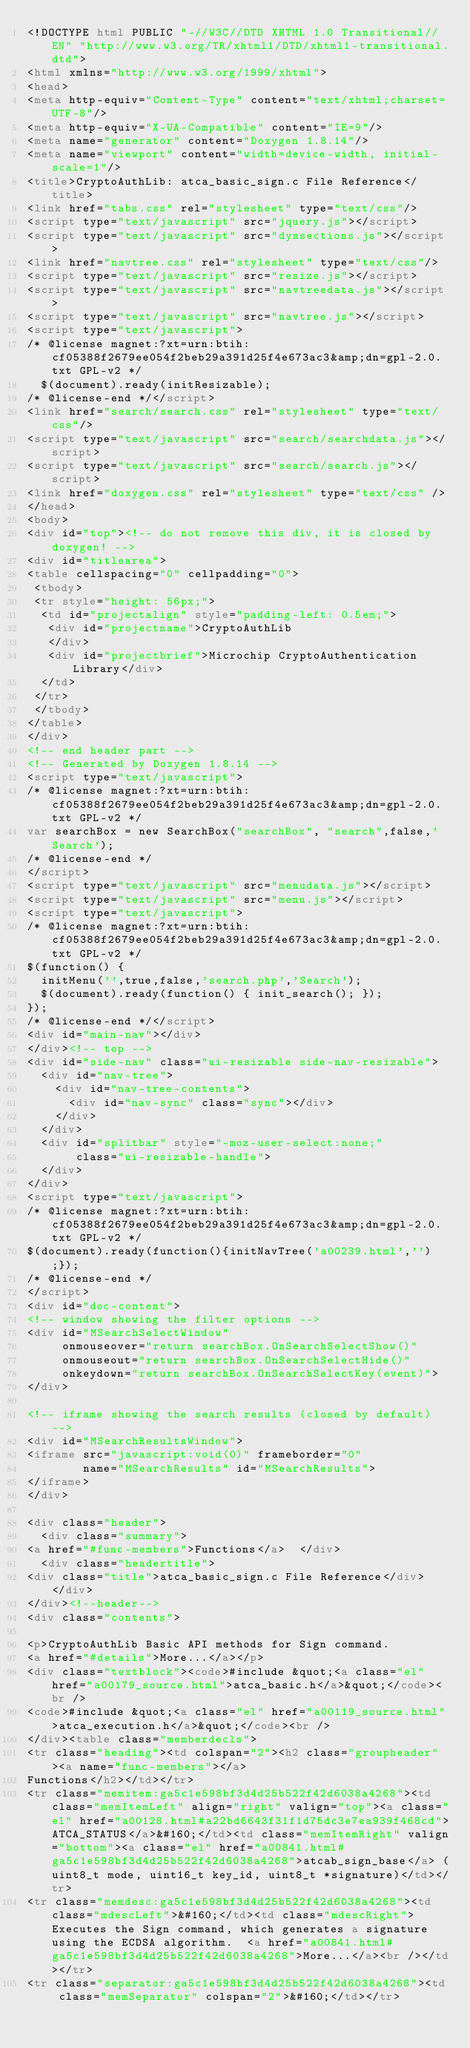<code> <loc_0><loc_0><loc_500><loc_500><_HTML_><!DOCTYPE html PUBLIC "-//W3C//DTD XHTML 1.0 Transitional//EN" "http://www.w3.org/TR/xhtml1/DTD/xhtml1-transitional.dtd">
<html xmlns="http://www.w3.org/1999/xhtml">
<head>
<meta http-equiv="Content-Type" content="text/xhtml;charset=UTF-8"/>
<meta http-equiv="X-UA-Compatible" content="IE=9"/>
<meta name="generator" content="Doxygen 1.8.14"/>
<meta name="viewport" content="width=device-width, initial-scale=1"/>
<title>CryptoAuthLib: atca_basic_sign.c File Reference</title>
<link href="tabs.css" rel="stylesheet" type="text/css"/>
<script type="text/javascript" src="jquery.js"></script>
<script type="text/javascript" src="dynsections.js"></script>
<link href="navtree.css" rel="stylesheet" type="text/css"/>
<script type="text/javascript" src="resize.js"></script>
<script type="text/javascript" src="navtreedata.js"></script>
<script type="text/javascript" src="navtree.js"></script>
<script type="text/javascript">
/* @license magnet:?xt=urn:btih:cf05388f2679ee054f2beb29a391d25f4e673ac3&amp;dn=gpl-2.0.txt GPL-v2 */
  $(document).ready(initResizable);
/* @license-end */</script>
<link href="search/search.css" rel="stylesheet" type="text/css"/>
<script type="text/javascript" src="search/searchdata.js"></script>
<script type="text/javascript" src="search/search.js"></script>
<link href="doxygen.css" rel="stylesheet" type="text/css" />
</head>
<body>
<div id="top"><!-- do not remove this div, it is closed by doxygen! -->
<div id="titlearea">
<table cellspacing="0" cellpadding="0">
 <tbody>
 <tr style="height: 56px;">
  <td id="projectalign" style="padding-left: 0.5em;">
   <div id="projectname">CryptoAuthLib
   </div>
   <div id="projectbrief">Microchip CryptoAuthentication Library</div>
  </td>
 </tr>
 </tbody>
</table>
</div>
<!-- end header part -->
<!-- Generated by Doxygen 1.8.14 -->
<script type="text/javascript">
/* @license magnet:?xt=urn:btih:cf05388f2679ee054f2beb29a391d25f4e673ac3&amp;dn=gpl-2.0.txt GPL-v2 */
var searchBox = new SearchBox("searchBox", "search",false,'Search');
/* @license-end */
</script>
<script type="text/javascript" src="menudata.js"></script>
<script type="text/javascript" src="menu.js"></script>
<script type="text/javascript">
/* @license magnet:?xt=urn:btih:cf05388f2679ee054f2beb29a391d25f4e673ac3&amp;dn=gpl-2.0.txt GPL-v2 */
$(function() {
  initMenu('',true,false,'search.php','Search');
  $(document).ready(function() { init_search(); });
});
/* @license-end */</script>
<div id="main-nav"></div>
</div><!-- top -->
<div id="side-nav" class="ui-resizable side-nav-resizable">
  <div id="nav-tree">
    <div id="nav-tree-contents">
      <div id="nav-sync" class="sync"></div>
    </div>
  </div>
  <div id="splitbar" style="-moz-user-select:none;" 
       class="ui-resizable-handle">
  </div>
</div>
<script type="text/javascript">
/* @license magnet:?xt=urn:btih:cf05388f2679ee054f2beb29a391d25f4e673ac3&amp;dn=gpl-2.0.txt GPL-v2 */
$(document).ready(function(){initNavTree('a00239.html','');});
/* @license-end */
</script>
<div id="doc-content">
<!-- window showing the filter options -->
<div id="MSearchSelectWindow"
     onmouseover="return searchBox.OnSearchSelectShow()"
     onmouseout="return searchBox.OnSearchSelectHide()"
     onkeydown="return searchBox.OnSearchSelectKey(event)">
</div>

<!-- iframe showing the search results (closed by default) -->
<div id="MSearchResultsWindow">
<iframe src="javascript:void(0)" frameborder="0" 
        name="MSearchResults" id="MSearchResults">
</iframe>
</div>

<div class="header">
  <div class="summary">
<a href="#func-members">Functions</a>  </div>
  <div class="headertitle">
<div class="title">atca_basic_sign.c File Reference</div>  </div>
</div><!--header-->
<div class="contents">

<p>CryptoAuthLib Basic API methods for Sign command.  
<a href="#details">More...</a></p>
<div class="textblock"><code>#include &quot;<a class="el" href="a00179_source.html">atca_basic.h</a>&quot;</code><br />
<code>#include &quot;<a class="el" href="a00119_source.html">atca_execution.h</a>&quot;</code><br />
</div><table class="memberdecls">
<tr class="heading"><td colspan="2"><h2 class="groupheader"><a name="func-members"></a>
Functions</h2></td></tr>
<tr class="memitem:ga5c1e598bf3d4d25b522f42d6038a4268"><td class="memItemLeft" align="right" valign="top"><a class="el" href="a00128.html#a22bd6643f31f1d75dc3e7ea939f468cd">ATCA_STATUS</a>&#160;</td><td class="memItemRight" valign="bottom"><a class="el" href="a00841.html#ga5c1e598bf3d4d25b522f42d6038a4268">atcab_sign_base</a> (uint8_t mode, uint16_t key_id, uint8_t *signature)</td></tr>
<tr class="memdesc:ga5c1e598bf3d4d25b522f42d6038a4268"><td class="mdescLeft">&#160;</td><td class="mdescRight">Executes the Sign command, which generates a signature using the ECDSA algorithm.  <a href="a00841.html#ga5c1e598bf3d4d25b522f42d6038a4268">More...</a><br /></td></tr>
<tr class="separator:ga5c1e598bf3d4d25b522f42d6038a4268"><td class="memSeparator" colspan="2">&#160;</td></tr></code> 